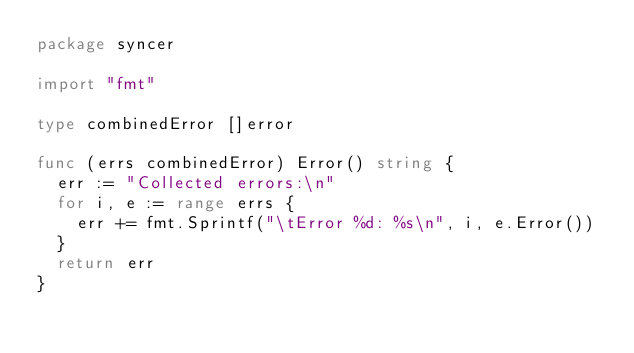Convert code to text. <code><loc_0><loc_0><loc_500><loc_500><_Go_>package syncer

import "fmt"

type combinedError []error

func (errs combinedError) Error() string {
	err := "Collected errors:\n"
	for i, e := range errs {
		err += fmt.Sprintf("\tError %d: %s\n", i, e.Error())
	}
	return err
}
</code> 